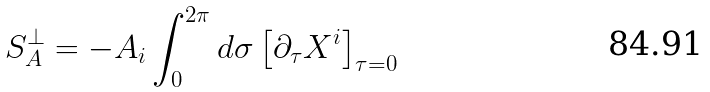Convert formula to latex. <formula><loc_0><loc_0><loc_500><loc_500>S _ { A } ^ { \perp } = - A _ { i } \int _ { 0 } ^ { 2 \pi } d \sigma \left [ \partial _ { \tau } X ^ { i } \right ] _ { \tau = 0 }</formula> 